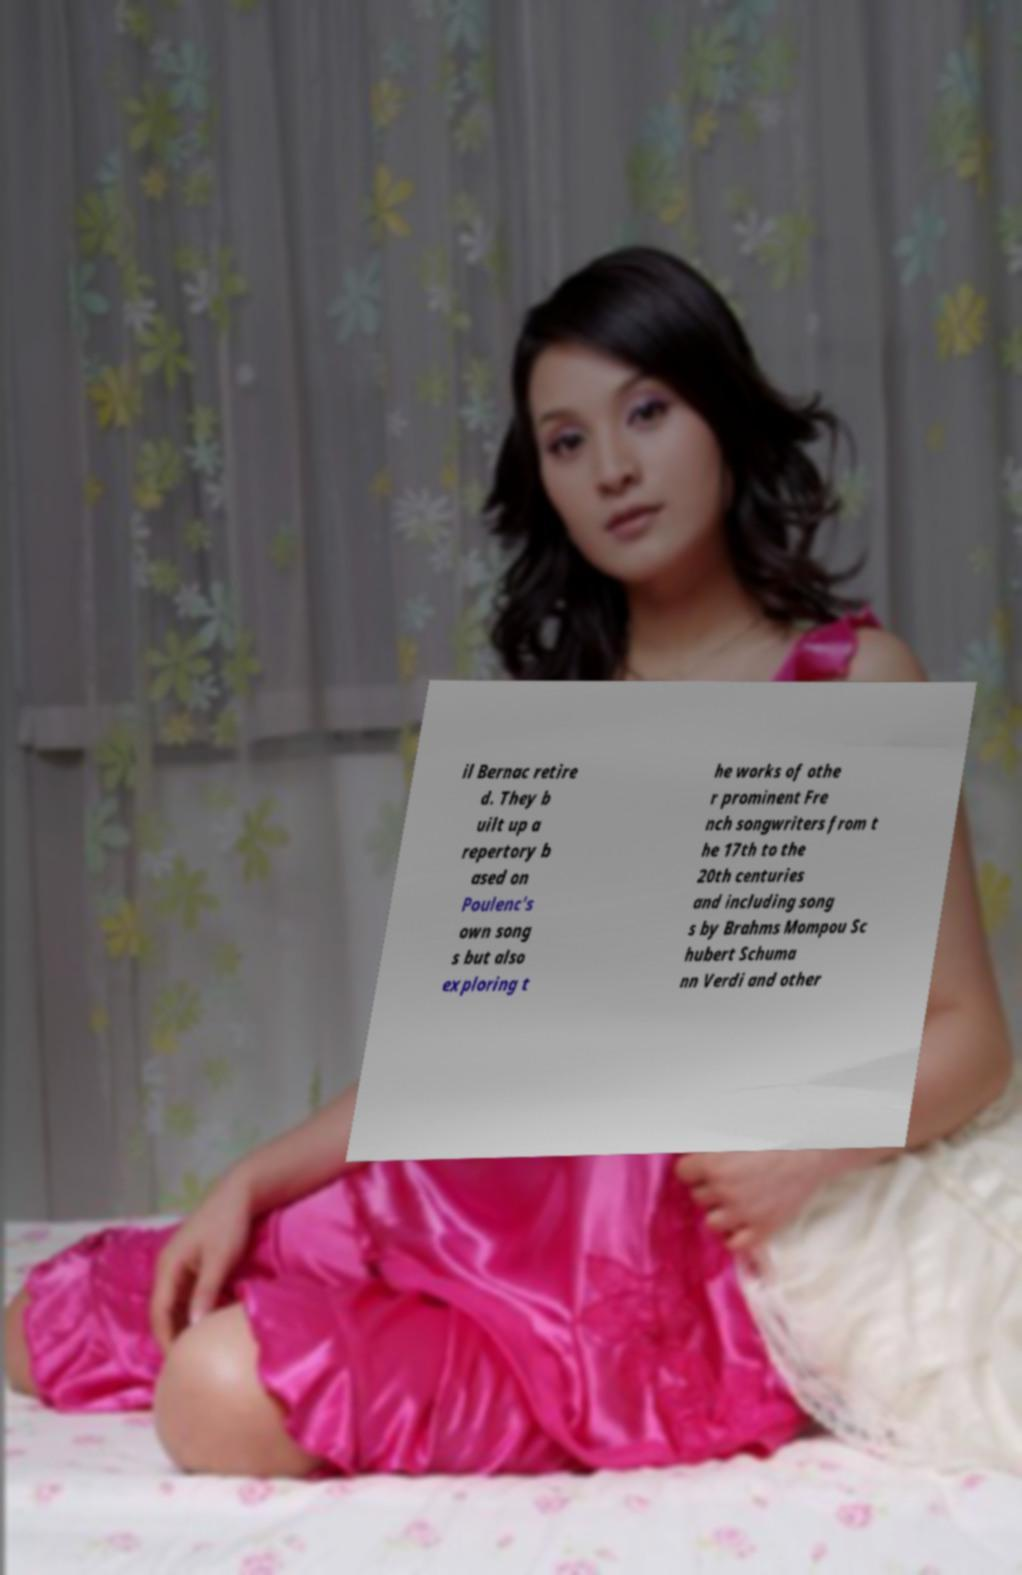There's text embedded in this image that I need extracted. Can you transcribe it verbatim? il Bernac retire d. They b uilt up a repertory b ased on Poulenc's own song s but also exploring t he works of othe r prominent Fre nch songwriters from t he 17th to the 20th centuries and including song s by Brahms Mompou Sc hubert Schuma nn Verdi and other 